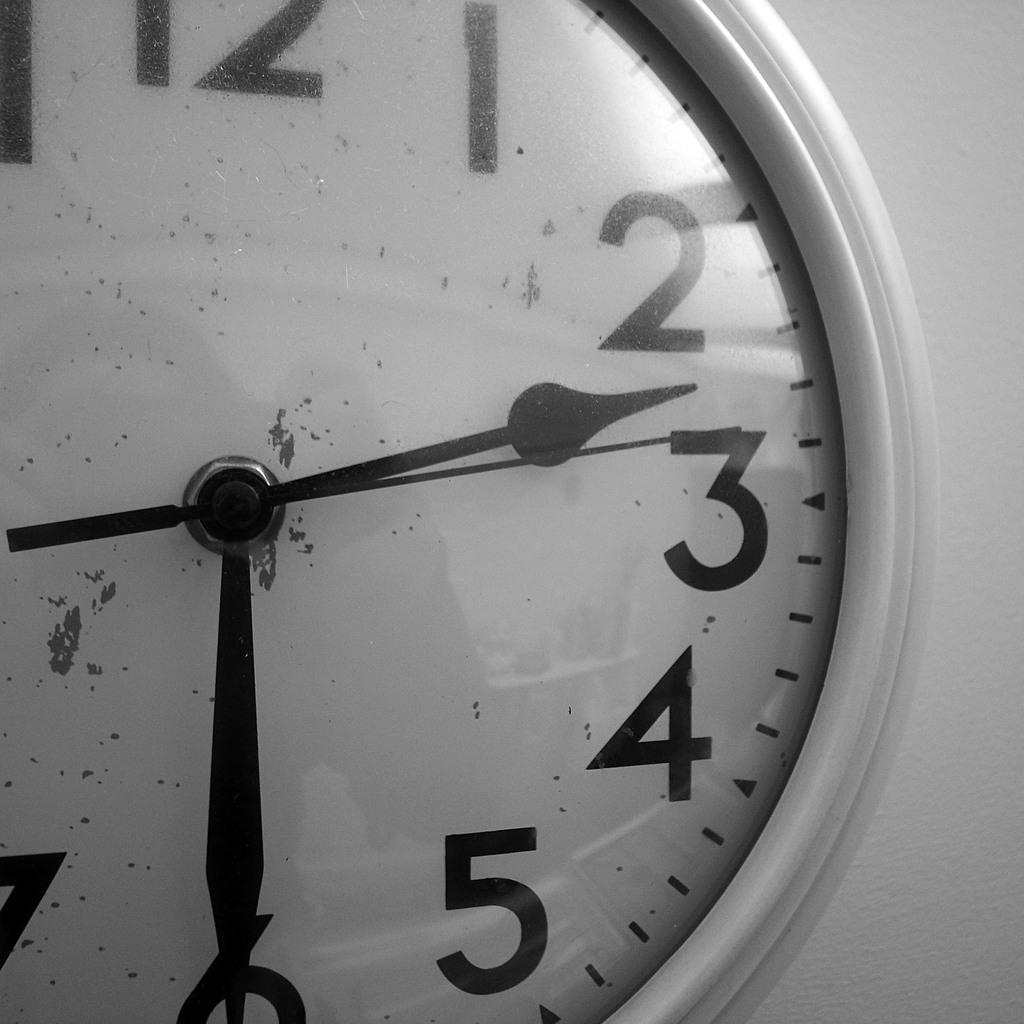Provide a one-sentence caption for the provided image. A wall clock with a white face and black hands showing the time of 2:30. 